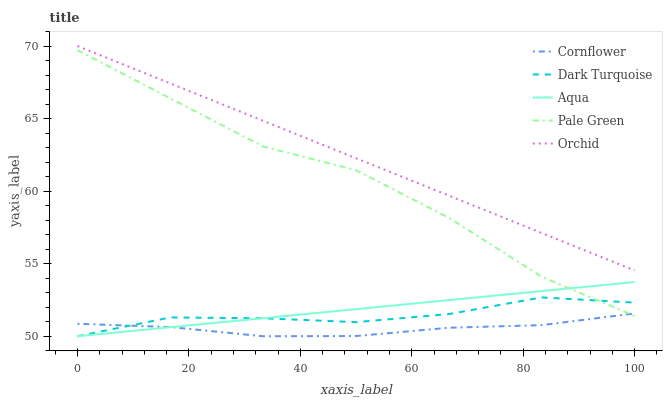Does Cornflower have the minimum area under the curve?
Answer yes or no. Yes. Does Orchid have the maximum area under the curve?
Answer yes or no. Yes. Does Pale Green have the minimum area under the curve?
Answer yes or no. No. Does Pale Green have the maximum area under the curve?
Answer yes or no. No. Is Aqua the smoothest?
Answer yes or no. Yes. Is Pale Green the roughest?
Answer yes or no. Yes. Is Cornflower the smoothest?
Answer yes or no. No. Is Cornflower the roughest?
Answer yes or no. No. Does Pale Green have the lowest value?
Answer yes or no. No. Does Pale Green have the highest value?
Answer yes or no. No. Is Cornflower less than Orchid?
Answer yes or no. Yes. Is Orchid greater than Aqua?
Answer yes or no. Yes. Does Cornflower intersect Orchid?
Answer yes or no. No. 